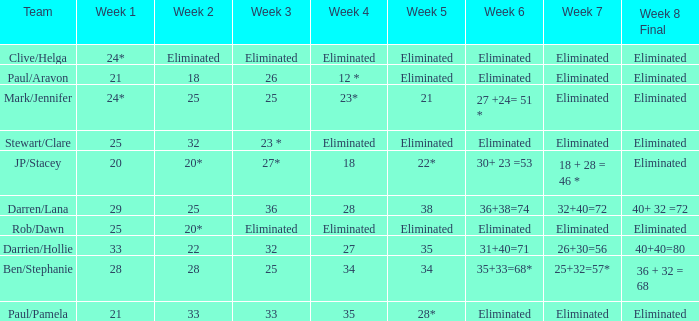Name the team for week 1 of 28 Ben/Stephanie. Could you parse the entire table as a dict? {'header': ['Team', 'Week 1', 'Week 2', 'Week 3', 'Week 4', 'Week 5', 'Week 6', 'Week 7', 'Week 8 Final'], 'rows': [['Clive/Helga', '24*', 'Eliminated', 'Eliminated', 'Eliminated', 'Eliminated', 'Eliminated', 'Eliminated', 'Eliminated'], ['Paul/Aravon', '21', '18', '26', '12 *', 'Eliminated', 'Eliminated', 'Eliminated', 'Eliminated'], ['Mark/Jennifer', '24*', '25', '25', '23*', '21', '27 +24= 51 *', 'Eliminated', 'Eliminated'], ['Stewart/Clare', '25', '32', '23 *', 'Eliminated', 'Eliminated', 'Eliminated', 'Eliminated', 'Eliminated'], ['JP/Stacey', '20', '20*', '27*', '18', '22*', '30+ 23 =53', '18 + 28 = 46 *', 'Eliminated'], ['Darren/Lana', '29', '25', '36', '28', '38', '36+38=74', '32+40=72', '40+ 32 =72'], ['Rob/Dawn', '25', '20*', 'Eliminated', 'Eliminated', 'Eliminated', 'Eliminated', 'Eliminated', 'Eliminated'], ['Darrien/Hollie', '33', '22', '32', '27', '35', '31+40=71', '26+30=56', '40+40=80'], ['Ben/Stephanie', '28', '28', '25', '34', '34', '35+33=68*', '25+32=57*', '36 + 32 = 68'], ['Paul/Pamela', '21', '33', '33', '35', '28*', 'Eliminated', 'Eliminated', 'Eliminated']]} 